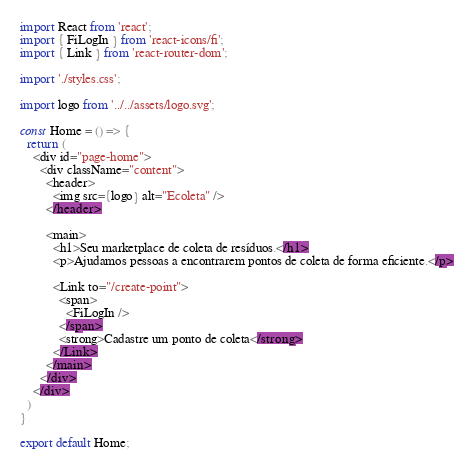Convert code to text. <code><loc_0><loc_0><loc_500><loc_500><_TypeScript_>import React from 'react';
import { FiLogIn } from 'react-icons/fi';
import { Link } from 'react-router-dom';

import './styles.css';

import logo from '../../assets/logo.svg';

const Home = () => {
  return (
    <div id="page-home">
      <div className="content">
        <header>
          <img src={logo} alt="Ecoleta" />
        </header>

        <main>
          <h1>Seu marketplace de coleta de resíduos.</h1>
          <p>Ajudamos pessoas a encontrarem pontos de coleta de forma eficiente.</p>

          <Link to="/create-point">
            <span>
              <FiLogIn />
            </span>
            <strong>Cadastre um ponto de coleta</strong>
          </Link>
        </main>
      </div>
    </div>
  )
}

export default Home;</code> 